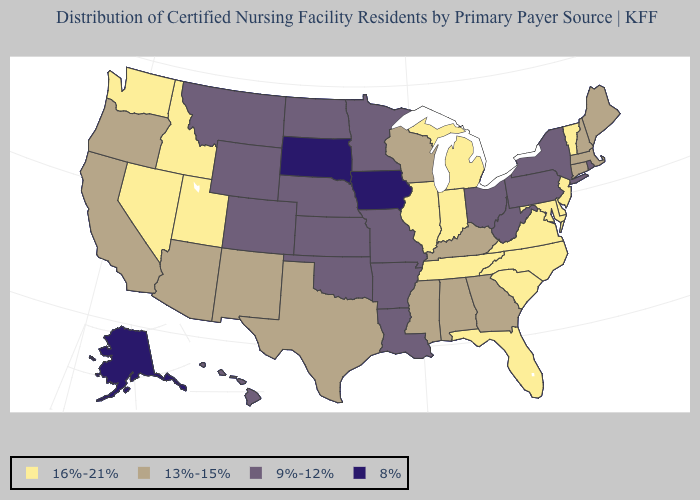Does Connecticut have a higher value than Wisconsin?
Answer briefly. No. Name the states that have a value in the range 13%-15%?
Give a very brief answer. Alabama, Arizona, California, Connecticut, Georgia, Kentucky, Maine, Massachusetts, Mississippi, New Hampshire, New Mexico, Oregon, Texas, Wisconsin. What is the value of Oregon?
Be succinct. 13%-15%. What is the value of Kentucky?
Be succinct. 13%-15%. Name the states that have a value in the range 13%-15%?
Answer briefly. Alabama, Arizona, California, Connecticut, Georgia, Kentucky, Maine, Massachusetts, Mississippi, New Hampshire, New Mexico, Oregon, Texas, Wisconsin. Among the states that border Oregon , which have the highest value?
Be succinct. Idaho, Nevada, Washington. What is the highest value in the MidWest ?
Keep it brief. 16%-21%. Does the map have missing data?
Quick response, please. No. Name the states that have a value in the range 8%?
Write a very short answer. Alaska, Iowa, South Dakota. What is the lowest value in states that border New Hampshire?
Keep it brief. 13%-15%. Name the states that have a value in the range 13%-15%?
Answer briefly. Alabama, Arizona, California, Connecticut, Georgia, Kentucky, Maine, Massachusetts, Mississippi, New Hampshire, New Mexico, Oregon, Texas, Wisconsin. What is the value of Maine?
Answer briefly. 13%-15%. Does Arkansas have a higher value than Alaska?
Be succinct. Yes. Among the states that border New Hampshire , does Vermont have the lowest value?
Be succinct. No. Does the map have missing data?
Answer briefly. No. 